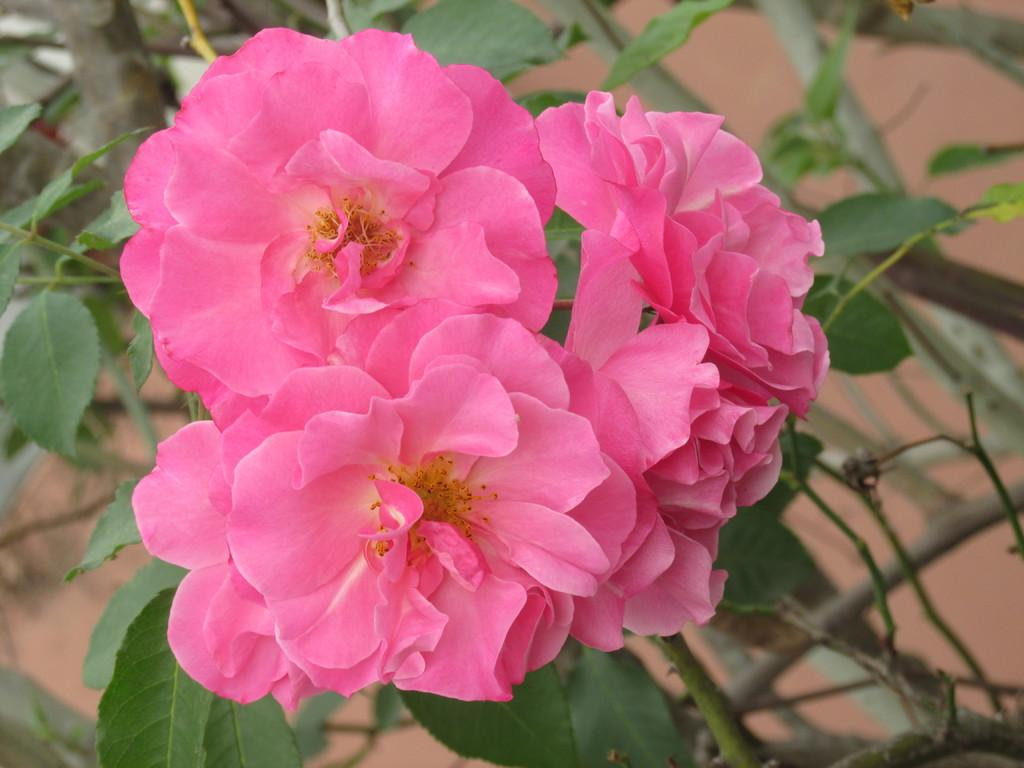What type of flowers can be seen in the image? There are pink flowers in the image. What color are the leaves associated with the flowers? There are green leaves in the image. Can you see a quill being used to write a suggestion near the river in the image? There is no quill, suggestion, or river present in the image. 